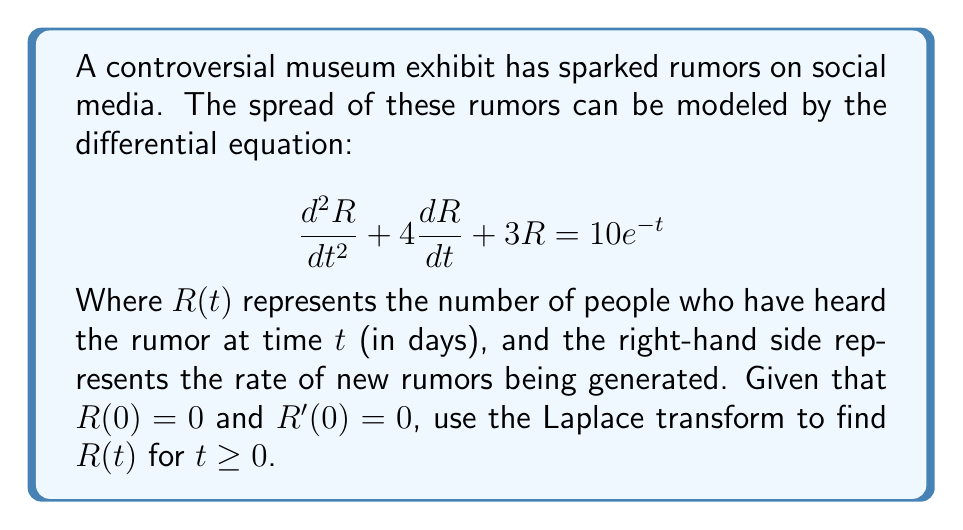Show me your answer to this math problem. Let's solve this step-by-step using the Laplace transform:

1) Take the Laplace transform of both sides of the equation:
   $$\mathcal{L}\{d^2R/dt^2 + 4dR/dt + 3R\} = \mathcal{L}\{10e^{-t}\}$$

2) Using Laplace transform properties:
   $$s^2R(s) - sR(0) - R'(0) + 4[sR(s) - R(0)] + 3R(s) = 10/(s+1)$$

3) Substitute the initial conditions $R(0) = 0$ and $R'(0) = 0$:
   $$s^2R(s) + 4sR(s) + 3R(s) = 10/(s+1)$$

4) Factor out $R(s)$:
   $$R(s)(s^2 + 4s + 3) = 10/(s+1)$$

5) Solve for $R(s)$:
   $$R(s) = \frac{10}{(s+1)(s^2 + 4s + 3)}$$

6) Decompose into partial fractions:
   $$R(s) = \frac{A}{s+1} + \frac{Bs+C}{s^2 + 4s + 3}$$

7) Solve for A, B, and C:
   $$A = 10/3, B = -10/3, C = -20/3$$

8) Rewrite $R(s)$:
   $$R(s) = \frac{10/3}{s+1} - \frac{10/3(s+2)}{s^2 + 4s + 3}$$

9) Take the inverse Laplace transform:
   $$R(t) = \frac{10}{3}e^{-t} - \frac{10}{3}e^{-2t}(\cosh t + 2\sinh t)$$

10) Simplify:
    $$R(t) = \frac{10}{3}e^{-t} - \frac{10}{3}e^{-t}(\cosh t + 2\sinh t)$$
    $$R(t) = \frac{10}{3}e^{-t}(1 - \cosh t - 2\sinh t)$$
Answer: $R(t) = \frac{10}{3}e^{-t}(1 - \cosh t - 2\sinh t)$ 